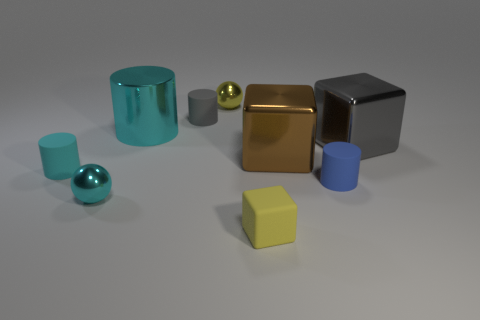There is a tiny cylinder that is to the right of the large brown metallic cube; are there any tiny yellow metal things behind it?
Your response must be concise. Yes. There is a small cyan thing that is the same shape as the small blue object; what is its material?
Provide a succinct answer. Rubber. Are there more tiny rubber cylinders than large metal cylinders?
Make the answer very short. Yes. There is a small rubber block; is it the same color as the big thing to the left of the yellow matte thing?
Ensure brevity in your answer.  No. The cylinder that is in front of the large shiny cylinder and behind the tiny blue matte cylinder is what color?
Keep it short and to the point. Cyan. What number of other things are there of the same material as the yellow block
Give a very brief answer. 3. Is the number of small brown spheres less than the number of small cylinders?
Your answer should be very brief. Yes. Does the brown cube have the same material as the large gray block behind the tiny cyan sphere?
Ensure brevity in your answer.  Yes. What shape is the gray thing that is on the left side of the tiny yellow metallic ball?
Give a very brief answer. Cylinder. Is there any other thing of the same color as the tiny cube?
Your response must be concise. Yes. 